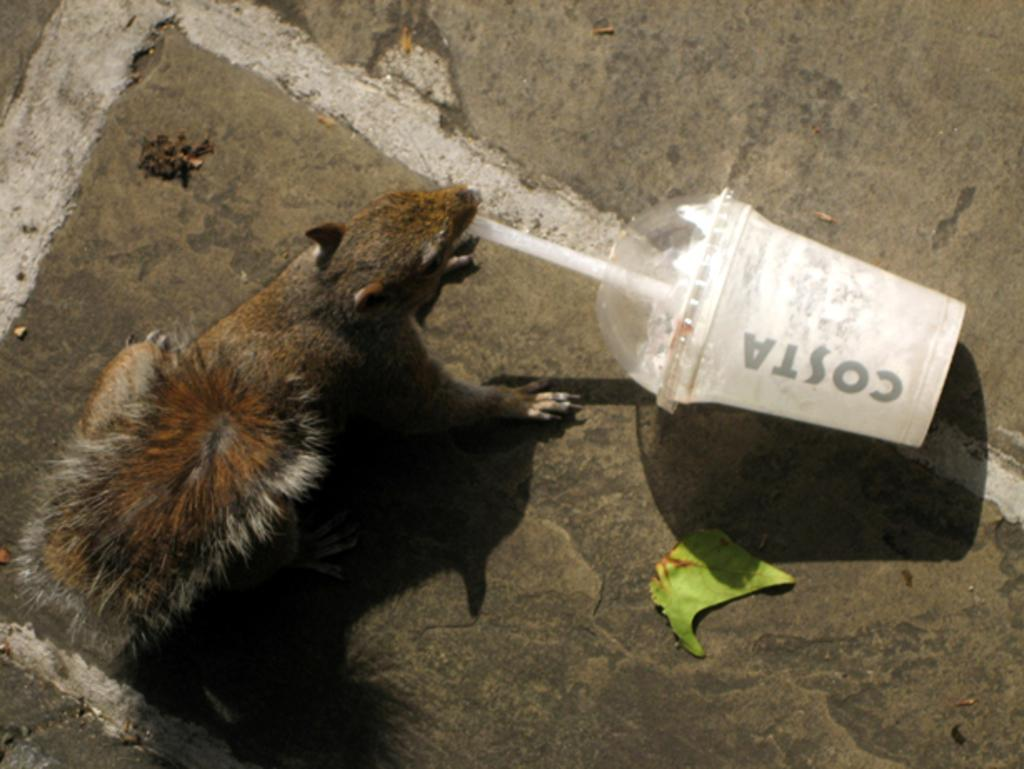What type of animal can be seen in the image? There is a squirrel in the image. What object is present in the image that is commonly used for holding liquids? There is a plastic bottle in the image. What natural element is visible on the right side of the image? There is a leaf on the right side of the image. What type of surface is visible at the bottom of the image? The bottom of the image features a rock surface. What type of discussion is taking place between the squirrel and the plastic bottle in the image? There is no discussion taking place between the squirrel and the plastic bottle in the image, as they are inanimate objects and cannot engage in conversation. 